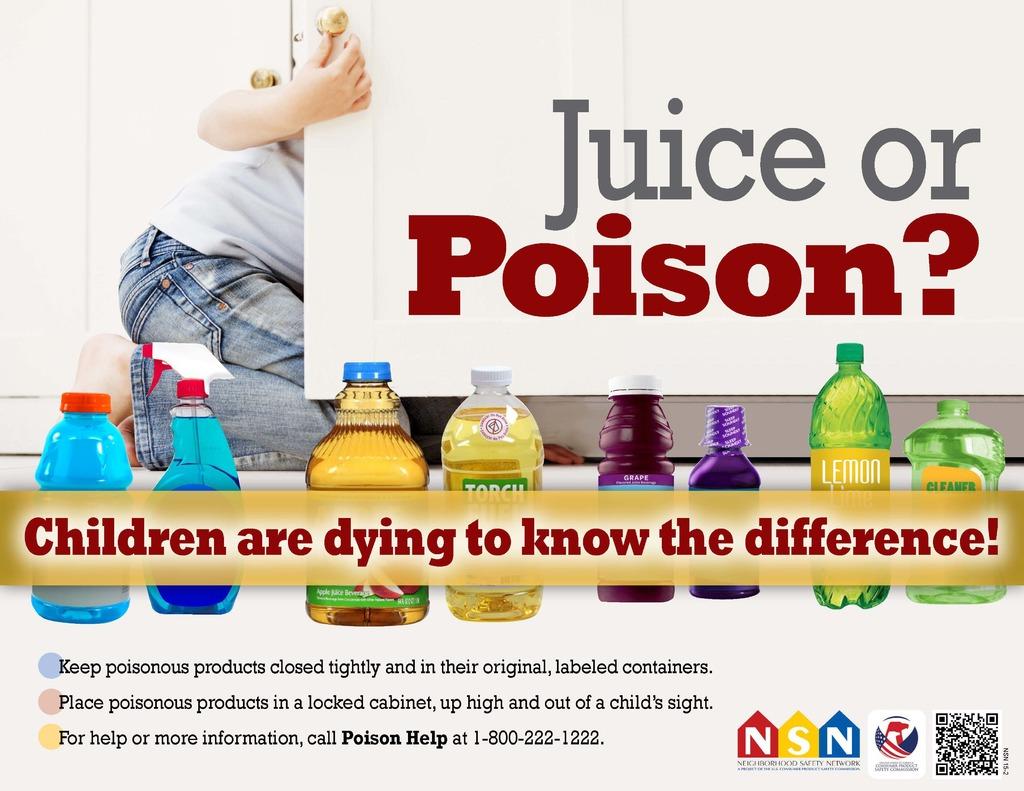What are happening to children?
Offer a very short reply. Dying. 